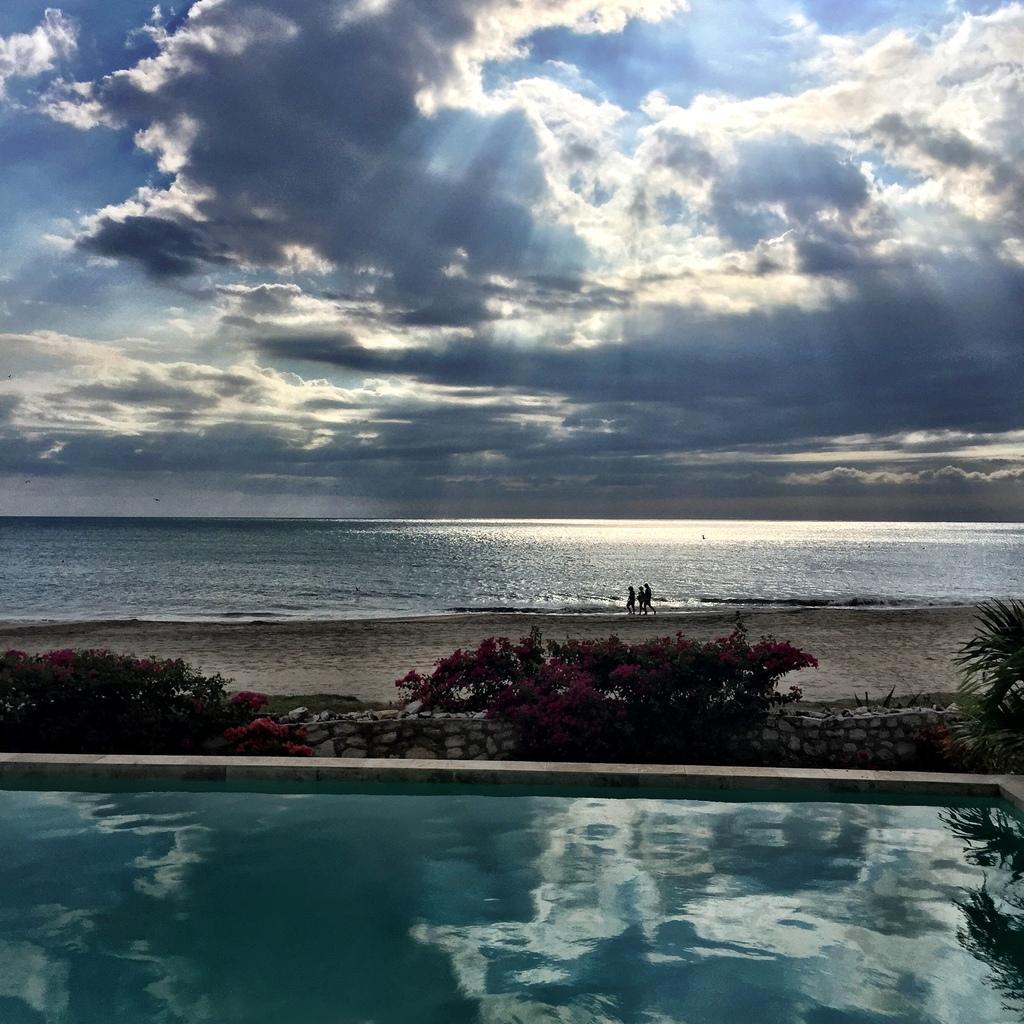Please provide a concise description of this image. In this picture I can see the pool in the foreground. I can see flower plants. I can see people on the side of a beach. I can see water. I can see clouds in the sky. 